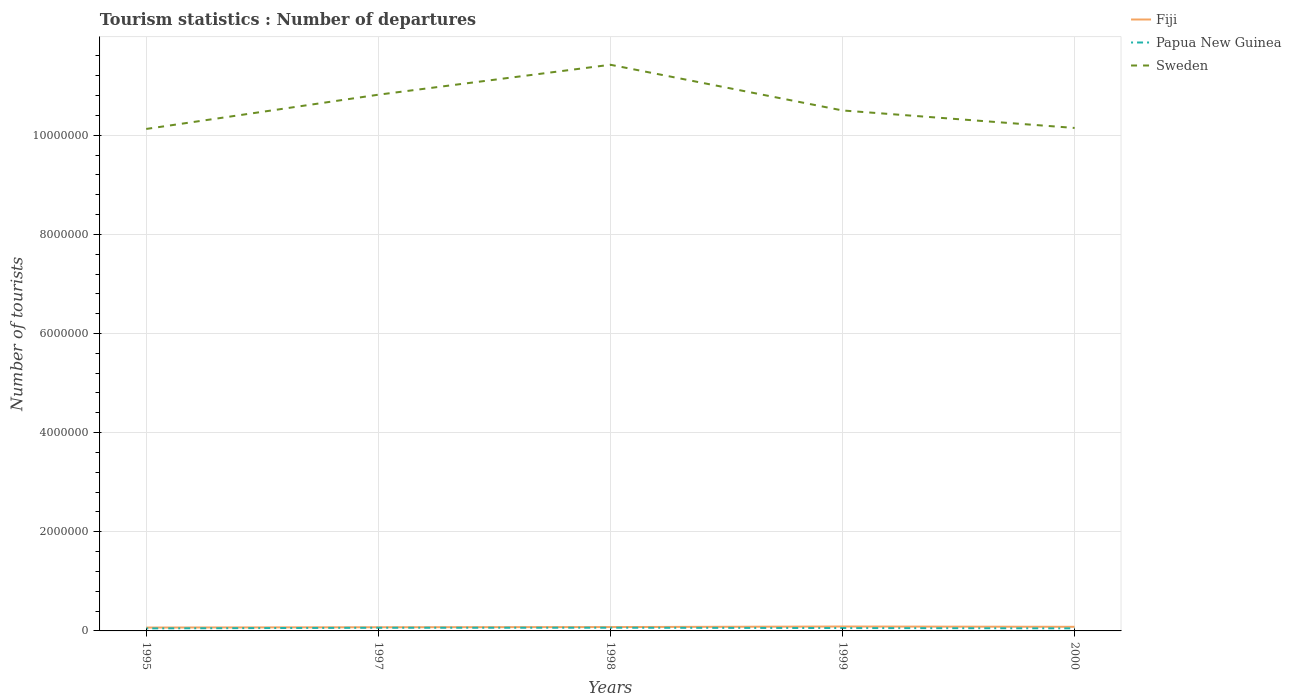How many different coloured lines are there?
Your answer should be compact. 3. Is the number of lines equal to the number of legend labels?
Ensure brevity in your answer.  Yes. Across all years, what is the maximum number of tourist departures in Sweden?
Offer a very short reply. 1.01e+07. In which year was the number of tourist departures in Sweden maximum?
Offer a terse response. 1995. What is the total number of tourist departures in Fiji in the graph?
Provide a succinct answer. -9000. What is the difference between the highest and the second highest number of tourist departures in Sweden?
Provide a succinct answer. 1.30e+06. Is the number of tourist departures in Papua New Guinea strictly greater than the number of tourist departures in Sweden over the years?
Provide a succinct answer. Yes. How many lines are there?
Keep it short and to the point. 3. How many years are there in the graph?
Your response must be concise. 5. What is the difference between two consecutive major ticks on the Y-axis?
Your response must be concise. 2.00e+06. Are the values on the major ticks of Y-axis written in scientific E-notation?
Give a very brief answer. No. How many legend labels are there?
Keep it short and to the point. 3. What is the title of the graph?
Ensure brevity in your answer.  Tourism statistics : Number of departures. What is the label or title of the X-axis?
Ensure brevity in your answer.  Years. What is the label or title of the Y-axis?
Your response must be concise. Number of tourists. What is the Number of tourists in Fiji in 1995?
Make the answer very short. 6.80e+04. What is the Number of tourists of Papua New Guinea in 1995?
Keep it short and to the point. 5.10e+04. What is the Number of tourists in Sweden in 1995?
Your answer should be compact. 1.01e+07. What is the Number of tourists in Fiji in 1997?
Offer a terse response. 7.40e+04. What is the Number of tourists of Papua New Guinea in 1997?
Provide a short and direct response. 6.40e+04. What is the Number of tourists of Sweden in 1997?
Give a very brief answer. 1.08e+07. What is the Number of tourists of Fiji in 1998?
Keep it short and to the point. 7.80e+04. What is the Number of tourists in Papua New Guinea in 1998?
Offer a terse response. 6.50e+04. What is the Number of tourists in Sweden in 1998?
Provide a succinct answer. 1.14e+07. What is the Number of tourists of Fiji in 1999?
Your answer should be very brief. 8.90e+04. What is the Number of tourists of Papua New Guinea in 1999?
Offer a very short reply. 5.80e+04. What is the Number of tourists of Sweden in 1999?
Provide a short and direct response. 1.05e+07. What is the Number of tourists of Fiji in 2000?
Make the answer very short. 8.30e+04. What is the Number of tourists of Papua New Guinea in 2000?
Your response must be concise. 5.20e+04. What is the Number of tourists in Sweden in 2000?
Your answer should be very brief. 1.01e+07. Across all years, what is the maximum Number of tourists of Fiji?
Your answer should be very brief. 8.90e+04. Across all years, what is the maximum Number of tourists in Papua New Guinea?
Provide a short and direct response. 6.50e+04. Across all years, what is the maximum Number of tourists in Sweden?
Your response must be concise. 1.14e+07. Across all years, what is the minimum Number of tourists of Fiji?
Provide a short and direct response. 6.80e+04. Across all years, what is the minimum Number of tourists of Papua New Guinea?
Ensure brevity in your answer.  5.10e+04. Across all years, what is the minimum Number of tourists in Sweden?
Ensure brevity in your answer.  1.01e+07. What is the total Number of tourists of Fiji in the graph?
Offer a very short reply. 3.92e+05. What is the total Number of tourists in Papua New Guinea in the graph?
Provide a short and direct response. 2.90e+05. What is the total Number of tourists of Sweden in the graph?
Offer a very short reply. 5.30e+07. What is the difference between the Number of tourists of Fiji in 1995 and that in 1997?
Give a very brief answer. -6000. What is the difference between the Number of tourists in Papua New Guinea in 1995 and that in 1997?
Offer a very short reply. -1.30e+04. What is the difference between the Number of tourists of Sweden in 1995 and that in 1997?
Keep it short and to the point. -6.91e+05. What is the difference between the Number of tourists in Papua New Guinea in 1995 and that in 1998?
Offer a very short reply. -1.40e+04. What is the difference between the Number of tourists in Sweden in 1995 and that in 1998?
Your answer should be very brief. -1.30e+06. What is the difference between the Number of tourists of Fiji in 1995 and that in 1999?
Offer a terse response. -2.10e+04. What is the difference between the Number of tourists in Papua New Guinea in 1995 and that in 1999?
Provide a succinct answer. -7000. What is the difference between the Number of tourists of Sweden in 1995 and that in 1999?
Offer a very short reply. -3.73e+05. What is the difference between the Number of tourists in Fiji in 1995 and that in 2000?
Your response must be concise. -1.50e+04. What is the difference between the Number of tourists in Papua New Guinea in 1995 and that in 2000?
Keep it short and to the point. -1000. What is the difference between the Number of tourists of Sweden in 1995 and that in 2000?
Offer a very short reply. -2.00e+04. What is the difference between the Number of tourists of Fiji in 1997 and that in 1998?
Offer a terse response. -4000. What is the difference between the Number of tourists in Papua New Guinea in 1997 and that in 1998?
Offer a terse response. -1000. What is the difference between the Number of tourists of Sweden in 1997 and that in 1998?
Your answer should be compact. -6.04e+05. What is the difference between the Number of tourists in Fiji in 1997 and that in 1999?
Your response must be concise. -1.50e+04. What is the difference between the Number of tourists of Papua New Guinea in 1997 and that in 1999?
Ensure brevity in your answer.  6000. What is the difference between the Number of tourists of Sweden in 1997 and that in 1999?
Offer a terse response. 3.18e+05. What is the difference between the Number of tourists in Fiji in 1997 and that in 2000?
Make the answer very short. -9000. What is the difference between the Number of tourists of Papua New Guinea in 1997 and that in 2000?
Make the answer very short. 1.20e+04. What is the difference between the Number of tourists in Sweden in 1997 and that in 2000?
Give a very brief answer. 6.71e+05. What is the difference between the Number of tourists in Fiji in 1998 and that in 1999?
Give a very brief answer. -1.10e+04. What is the difference between the Number of tourists in Papua New Guinea in 1998 and that in 1999?
Keep it short and to the point. 7000. What is the difference between the Number of tourists in Sweden in 1998 and that in 1999?
Provide a succinct answer. 9.22e+05. What is the difference between the Number of tourists of Fiji in 1998 and that in 2000?
Make the answer very short. -5000. What is the difference between the Number of tourists of Papua New Guinea in 1998 and that in 2000?
Your answer should be compact. 1.30e+04. What is the difference between the Number of tourists in Sweden in 1998 and that in 2000?
Offer a very short reply. 1.28e+06. What is the difference between the Number of tourists of Fiji in 1999 and that in 2000?
Make the answer very short. 6000. What is the difference between the Number of tourists of Papua New Guinea in 1999 and that in 2000?
Your answer should be compact. 6000. What is the difference between the Number of tourists of Sweden in 1999 and that in 2000?
Your response must be concise. 3.53e+05. What is the difference between the Number of tourists of Fiji in 1995 and the Number of tourists of Papua New Guinea in 1997?
Your answer should be very brief. 4000. What is the difference between the Number of tourists in Fiji in 1995 and the Number of tourists in Sweden in 1997?
Offer a very short reply. -1.08e+07. What is the difference between the Number of tourists of Papua New Guinea in 1995 and the Number of tourists of Sweden in 1997?
Offer a very short reply. -1.08e+07. What is the difference between the Number of tourists in Fiji in 1995 and the Number of tourists in Papua New Guinea in 1998?
Offer a very short reply. 3000. What is the difference between the Number of tourists of Fiji in 1995 and the Number of tourists of Sweden in 1998?
Your answer should be very brief. -1.14e+07. What is the difference between the Number of tourists in Papua New Guinea in 1995 and the Number of tourists in Sweden in 1998?
Your response must be concise. -1.14e+07. What is the difference between the Number of tourists in Fiji in 1995 and the Number of tourists in Sweden in 1999?
Your answer should be very brief. -1.04e+07. What is the difference between the Number of tourists in Papua New Guinea in 1995 and the Number of tourists in Sweden in 1999?
Give a very brief answer. -1.04e+07. What is the difference between the Number of tourists in Fiji in 1995 and the Number of tourists in Papua New Guinea in 2000?
Keep it short and to the point. 1.60e+04. What is the difference between the Number of tourists of Fiji in 1995 and the Number of tourists of Sweden in 2000?
Keep it short and to the point. -1.01e+07. What is the difference between the Number of tourists of Papua New Guinea in 1995 and the Number of tourists of Sweden in 2000?
Offer a very short reply. -1.01e+07. What is the difference between the Number of tourists of Fiji in 1997 and the Number of tourists of Papua New Guinea in 1998?
Offer a terse response. 9000. What is the difference between the Number of tourists of Fiji in 1997 and the Number of tourists of Sweden in 1998?
Your answer should be very brief. -1.13e+07. What is the difference between the Number of tourists in Papua New Guinea in 1997 and the Number of tourists in Sweden in 1998?
Keep it short and to the point. -1.14e+07. What is the difference between the Number of tourists of Fiji in 1997 and the Number of tourists of Papua New Guinea in 1999?
Provide a succinct answer. 1.60e+04. What is the difference between the Number of tourists in Fiji in 1997 and the Number of tourists in Sweden in 1999?
Make the answer very short. -1.04e+07. What is the difference between the Number of tourists of Papua New Guinea in 1997 and the Number of tourists of Sweden in 1999?
Your answer should be compact. -1.04e+07. What is the difference between the Number of tourists in Fiji in 1997 and the Number of tourists in Papua New Guinea in 2000?
Offer a terse response. 2.20e+04. What is the difference between the Number of tourists of Fiji in 1997 and the Number of tourists of Sweden in 2000?
Provide a succinct answer. -1.01e+07. What is the difference between the Number of tourists of Papua New Guinea in 1997 and the Number of tourists of Sweden in 2000?
Your response must be concise. -1.01e+07. What is the difference between the Number of tourists of Fiji in 1998 and the Number of tourists of Papua New Guinea in 1999?
Provide a short and direct response. 2.00e+04. What is the difference between the Number of tourists in Fiji in 1998 and the Number of tourists in Sweden in 1999?
Offer a very short reply. -1.04e+07. What is the difference between the Number of tourists in Papua New Guinea in 1998 and the Number of tourists in Sweden in 1999?
Ensure brevity in your answer.  -1.04e+07. What is the difference between the Number of tourists in Fiji in 1998 and the Number of tourists in Papua New Guinea in 2000?
Give a very brief answer. 2.60e+04. What is the difference between the Number of tourists of Fiji in 1998 and the Number of tourists of Sweden in 2000?
Give a very brief answer. -1.01e+07. What is the difference between the Number of tourists of Papua New Guinea in 1998 and the Number of tourists of Sweden in 2000?
Ensure brevity in your answer.  -1.01e+07. What is the difference between the Number of tourists in Fiji in 1999 and the Number of tourists in Papua New Guinea in 2000?
Offer a terse response. 3.70e+04. What is the difference between the Number of tourists in Fiji in 1999 and the Number of tourists in Sweden in 2000?
Keep it short and to the point. -1.01e+07. What is the difference between the Number of tourists of Papua New Guinea in 1999 and the Number of tourists of Sweden in 2000?
Provide a short and direct response. -1.01e+07. What is the average Number of tourists in Fiji per year?
Your answer should be very brief. 7.84e+04. What is the average Number of tourists in Papua New Guinea per year?
Ensure brevity in your answer.  5.80e+04. What is the average Number of tourists in Sweden per year?
Give a very brief answer. 1.06e+07. In the year 1995, what is the difference between the Number of tourists of Fiji and Number of tourists of Papua New Guinea?
Offer a terse response. 1.70e+04. In the year 1995, what is the difference between the Number of tourists of Fiji and Number of tourists of Sweden?
Offer a terse response. -1.01e+07. In the year 1995, what is the difference between the Number of tourists of Papua New Guinea and Number of tourists of Sweden?
Make the answer very short. -1.01e+07. In the year 1997, what is the difference between the Number of tourists in Fiji and Number of tourists in Papua New Guinea?
Make the answer very short. 10000. In the year 1997, what is the difference between the Number of tourists in Fiji and Number of tourists in Sweden?
Ensure brevity in your answer.  -1.07e+07. In the year 1997, what is the difference between the Number of tourists in Papua New Guinea and Number of tourists in Sweden?
Give a very brief answer. -1.08e+07. In the year 1998, what is the difference between the Number of tourists in Fiji and Number of tourists in Papua New Guinea?
Give a very brief answer. 1.30e+04. In the year 1998, what is the difference between the Number of tourists in Fiji and Number of tourists in Sweden?
Provide a short and direct response. -1.13e+07. In the year 1998, what is the difference between the Number of tourists in Papua New Guinea and Number of tourists in Sweden?
Your response must be concise. -1.14e+07. In the year 1999, what is the difference between the Number of tourists of Fiji and Number of tourists of Papua New Guinea?
Give a very brief answer. 3.10e+04. In the year 1999, what is the difference between the Number of tourists of Fiji and Number of tourists of Sweden?
Offer a terse response. -1.04e+07. In the year 1999, what is the difference between the Number of tourists of Papua New Guinea and Number of tourists of Sweden?
Give a very brief answer. -1.04e+07. In the year 2000, what is the difference between the Number of tourists in Fiji and Number of tourists in Papua New Guinea?
Your answer should be compact. 3.10e+04. In the year 2000, what is the difference between the Number of tourists of Fiji and Number of tourists of Sweden?
Offer a very short reply. -1.01e+07. In the year 2000, what is the difference between the Number of tourists of Papua New Guinea and Number of tourists of Sweden?
Your answer should be compact. -1.01e+07. What is the ratio of the Number of tourists in Fiji in 1995 to that in 1997?
Offer a very short reply. 0.92. What is the ratio of the Number of tourists of Papua New Guinea in 1995 to that in 1997?
Make the answer very short. 0.8. What is the ratio of the Number of tourists of Sweden in 1995 to that in 1997?
Your answer should be compact. 0.94. What is the ratio of the Number of tourists in Fiji in 1995 to that in 1998?
Provide a short and direct response. 0.87. What is the ratio of the Number of tourists of Papua New Guinea in 1995 to that in 1998?
Your response must be concise. 0.78. What is the ratio of the Number of tourists of Sweden in 1995 to that in 1998?
Offer a very short reply. 0.89. What is the ratio of the Number of tourists in Fiji in 1995 to that in 1999?
Offer a very short reply. 0.76. What is the ratio of the Number of tourists of Papua New Guinea in 1995 to that in 1999?
Ensure brevity in your answer.  0.88. What is the ratio of the Number of tourists of Sweden in 1995 to that in 1999?
Make the answer very short. 0.96. What is the ratio of the Number of tourists in Fiji in 1995 to that in 2000?
Provide a short and direct response. 0.82. What is the ratio of the Number of tourists in Papua New Guinea in 1995 to that in 2000?
Ensure brevity in your answer.  0.98. What is the ratio of the Number of tourists in Sweden in 1995 to that in 2000?
Your response must be concise. 1. What is the ratio of the Number of tourists in Fiji in 1997 to that in 1998?
Your answer should be very brief. 0.95. What is the ratio of the Number of tourists of Papua New Guinea in 1997 to that in 1998?
Keep it short and to the point. 0.98. What is the ratio of the Number of tourists in Sweden in 1997 to that in 1998?
Keep it short and to the point. 0.95. What is the ratio of the Number of tourists of Fiji in 1997 to that in 1999?
Ensure brevity in your answer.  0.83. What is the ratio of the Number of tourists of Papua New Guinea in 1997 to that in 1999?
Your answer should be very brief. 1.1. What is the ratio of the Number of tourists in Sweden in 1997 to that in 1999?
Give a very brief answer. 1.03. What is the ratio of the Number of tourists of Fiji in 1997 to that in 2000?
Offer a terse response. 0.89. What is the ratio of the Number of tourists of Papua New Guinea in 1997 to that in 2000?
Ensure brevity in your answer.  1.23. What is the ratio of the Number of tourists in Sweden in 1997 to that in 2000?
Your answer should be compact. 1.07. What is the ratio of the Number of tourists of Fiji in 1998 to that in 1999?
Your response must be concise. 0.88. What is the ratio of the Number of tourists in Papua New Guinea in 1998 to that in 1999?
Offer a very short reply. 1.12. What is the ratio of the Number of tourists of Sweden in 1998 to that in 1999?
Your answer should be very brief. 1.09. What is the ratio of the Number of tourists of Fiji in 1998 to that in 2000?
Ensure brevity in your answer.  0.94. What is the ratio of the Number of tourists of Papua New Guinea in 1998 to that in 2000?
Your answer should be compact. 1.25. What is the ratio of the Number of tourists of Sweden in 1998 to that in 2000?
Provide a succinct answer. 1.13. What is the ratio of the Number of tourists in Fiji in 1999 to that in 2000?
Your answer should be very brief. 1.07. What is the ratio of the Number of tourists of Papua New Guinea in 1999 to that in 2000?
Offer a terse response. 1.12. What is the ratio of the Number of tourists in Sweden in 1999 to that in 2000?
Keep it short and to the point. 1.03. What is the difference between the highest and the second highest Number of tourists of Fiji?
Your answer should be compact. 6000. What is the difference between the highest and the second highest Number of tourists of Sweden?
Keep it short and to the point. 6.04e+05. What is the difference between the highest and the lowest Number of tourists in Fiji?
Make the answer very short. 2.10e+04. What is the difference between the highest and the lowest Number of tourists in Papua New Guinea?
Your answer should be compact. 1.40e+04. What is the difference between the highest and the lowest Number of tourists of Sweden?
Offer a terse response. 1.30e+06. 